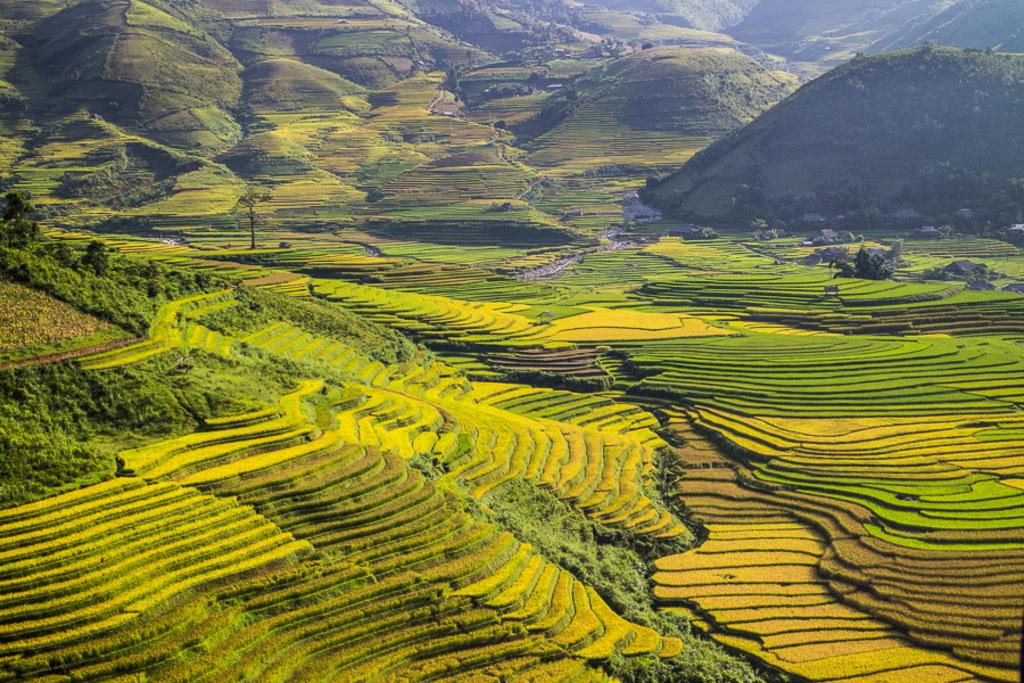What type of landscape is depicted in the image? There is a green farmland in the image. What can be seen in the distance behind the farmland? Mountains and trees are visible in the background of the image. How many feathers are on the birthday cake in the image? There is no birthday cake or feathers present in the image. 